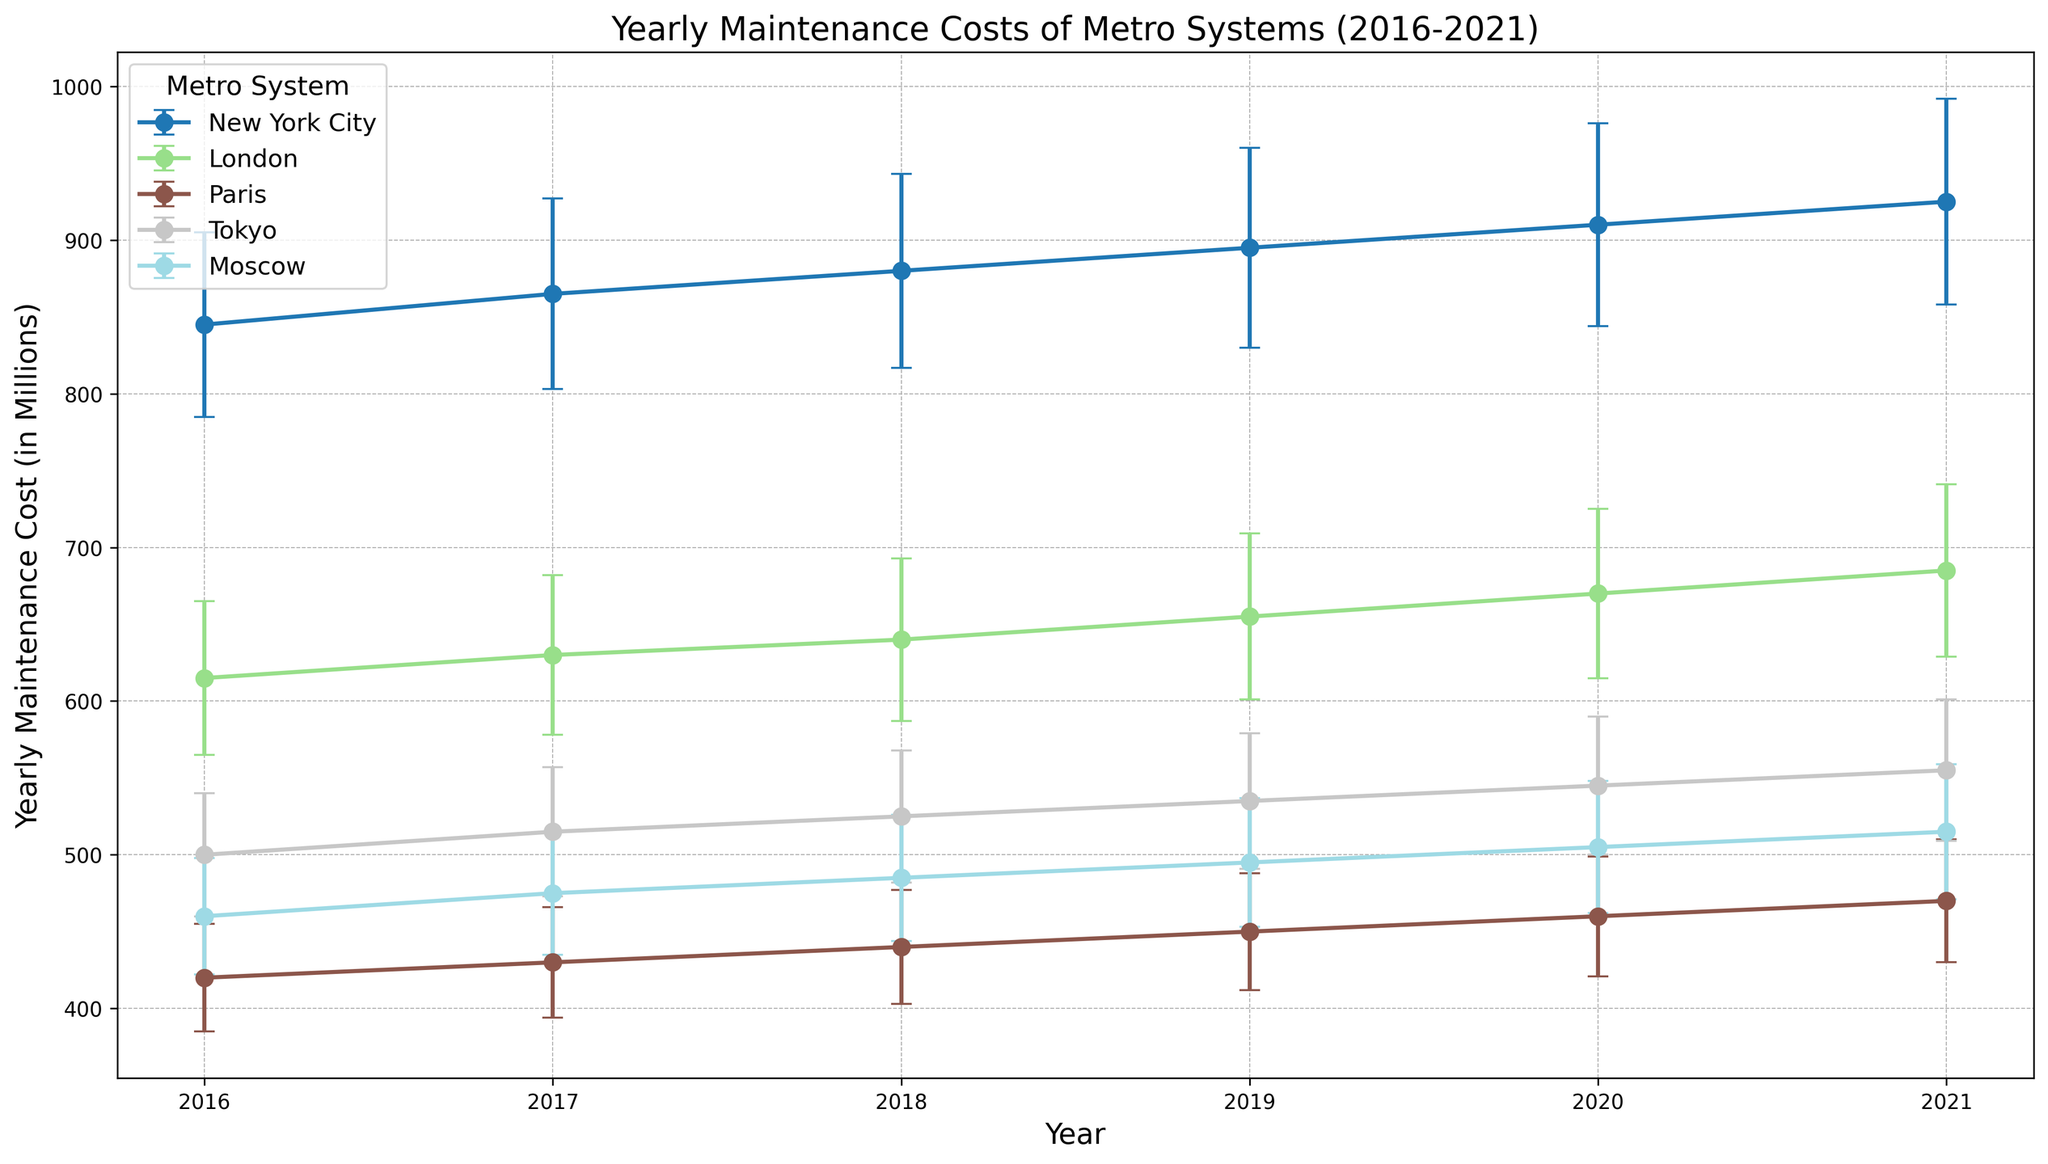Which metro system had the highest yearly maintenance cost in 2021? To find the metro system with the highest yearly maintenance cost in 2021, look for the highest data point in the year 2021 across all lines.
Answer: New York City By how much did New York City's yearly maintenance cost increase from 2016 to 2021? Subtract the maintenance cost of New York City in 2016 (845 million) from its cost in 2021 (925 million).
Answer: 80 million What is the average yearly maintenance cost of the Tokyo metro system across all years shown? Add up Tokyo's yearly maintenance costs (500, 515, 525, 535, 545, 555) and then divide by 6 (the number of years). The total is 3175 million, and the average is 3175 / 6.
Answer: Approximately 529.17 million Which metro system consistently had the lowest yearly maintenance cost over the years shown? Compare the yearly maintenance costs of all metro systems over the years. Paris always has the lowest maintenance costs when looking at the trends in the data.
Answer: Paris What is the total maintenance cost for the London metro system from 2016 to 2021? Sum the yearly maintenance costs for the London metro system (615, 630, 640, 655, 670, 685 million). The total is 3895 million.
Answer: 3895 million Which year had the largest increase in yearly maintenance cost for the Moscow metro system, and how much was the increase? Look at the yearly maintenance costs for Moscow and identify the year-over-year differences. The largest increase is from 2019 (495 million) to 2020 (505 million), which is 10 million.
Answer: 2019 to 2020, 10 million What is the range of yearly maintenance costs for the Paris metro system across the years shown? Subtract the lowest yearly maintenance cost (420 million in 2016) from the highest yearly maintenance cost (470 million in 2021).
Answer: 50 million How does the standard deviation of the yearly maintenance costs for Tokyo compare with that of London for the year 2020? Look at the error bars representing standard deviations for Tokyo (45 million) and London (55 million) in 2020 and compare them.
Answer: Tokyo's standard deviation is smaller By how much did the yearly maintenance cost for the Paris metro system change from 2016 to 2017? Subtract the maintenance cost of Paris in 2016 (420 million) from its cost in 2017 (430 million).
Answer: 10 million 